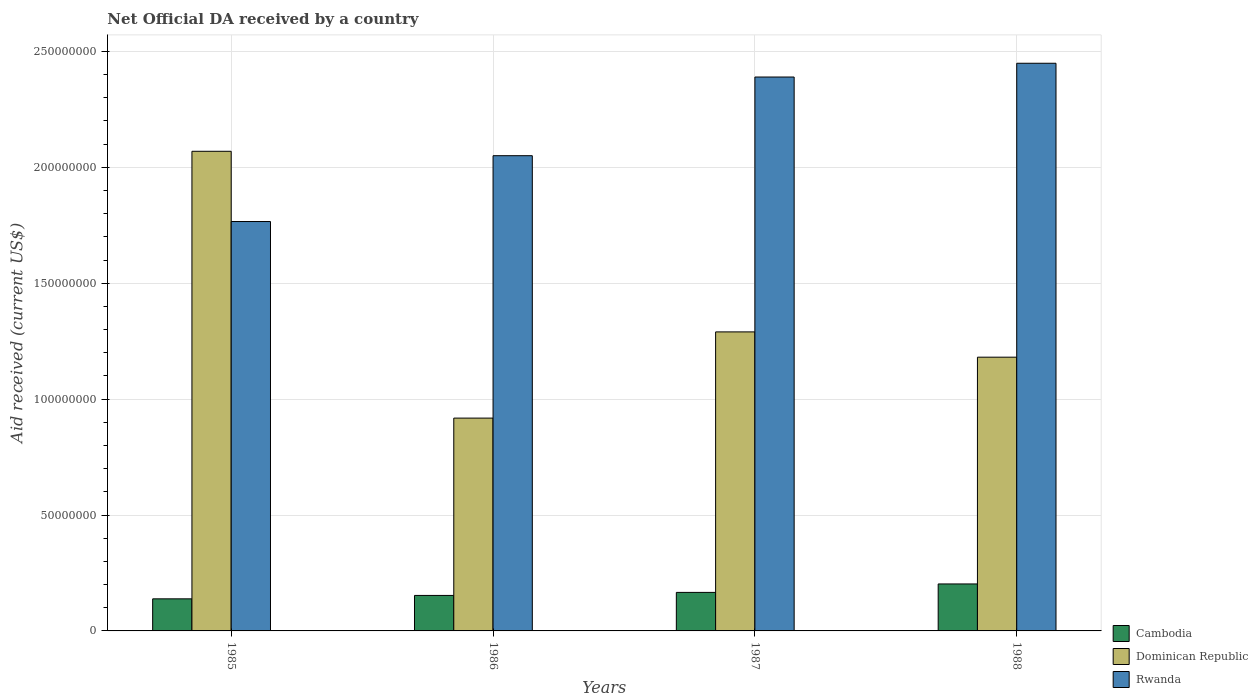How many groups of bars are there?
Make the answer very short. 4. How many bars are there on the 1st tick from the left?
Offer a very short reply. 3. How many bars are there on the 2nd tick from the right?
Offer a terse response. 3. In how many cases, is the number of bars for a given year not equal to the number of legend labels?
Provide a short and direct response. 0. What is the net official development assistance aid received in Cambodia in 1986?
Offer a very short reply. 1.53e+07. Across all years, what is the maximum net official development assistance aid received in Rwanda?
Offer a terse response. 2.45e+08. Across all years, what is the minimum net official development assistance aid received in Rwanda?
Offer a very short reply. 1.77e+08. In which year was the net official development assistance aid received in Cambodia minimum?
Keep it short and to the point. 1985. What is the total net official development assistance aid received in Rwanda in the graph?
Provide a succinct answer. 8.66e+08. What is the difference between the net official development assistance aid received in Dominican Republic in 1985 and that in 1986?
Give a very brief answer. 1.15e+08. What is the difference between the net official development assistance aid received in Rwanda in 1986 and the net official development assistance aid received in Cambodia in 1988?
Provide a succinct answer. 1.85e+08. What is the average net official development assistance aid received in Dominican Republic per year?
Make the answer very short. 1.36e+08. In the year 1986, what is the difference between the net official development assistance aid received in Rwanda and net official development assistance aid received in Dominican Republic?
Provide a succinct answer. 1.13e+08. In how many years, is the net official development assistance aid received in Cambodia greater than 40000000 US$?
Your response must be concise. 0. What is the ratio of the net official development assistance aid received in Dominican Republic in 1986 to that in 1988?
Make the answer very short. 0.78. Is the difference between the net official development assistance aid received in Rwanda in 1987 and 1988 greater than the difference between the net official development assistance aid received in Dominican Republic in 1987 and 1988?
Provide a succinct answer. No. What is the difference between the highest and the second highest net official development assistance aid received in Dominican Republic?
Keep it short and to the point. 7.79e+07. What is the difference between the highest and the lowest net official development assistance aid received in Cambodia?
Your response must be concise. 6.43e+06. What does the 3rd bar from the left in 1986 represents?
Your answer should be very brief. Rwanda. What does the 2nd bar from the right in 1988 represents?
Offer a terse response. Dominican Republic. Are all the bars in the graph horizontal?
Your response must be concise. No. How many years are there in the graph?
Offer a terse response. 4. What is the difference between two consecutive major ticks on the Y-axis?
Your answer should be compact. 5.00e+07. Where does the legend appear in the graph?
Ensure brevity in your answer.  Bottom right. How many legend labels are there?
Provide a succinct answer. 3. What is the title of the graph?
Offer a terse response. Net Official DA received by a country. What is the label or title of the X-axis?
Provide a succinct answer. Years. What is the label or title of the Y-axis?
Your response must be concise. Aid received (current US$). What is the Aid received (current US$) of Cambodia in 1985?
Offer a terse response. 1.38e+07. What is the Aid received (current US$) in Dominican Republic in 1985?
Ensure brevity in your answer.  2.07e+08. What is the Aid received (current US$) of Rwanda in 1985?
Give a very brief answer. 1.77e+08. What is the Aid received (current US$) in Cambodia in 1986?
Provide a succinct answer. 1.53e+07. What is the Aid received (current US$) of Dominican Republic in 1986?
Give a very brief answer. 9.18e+07. What is the Aid received (current US$) in Rwanda in 1986?
Give a very brief answer. 2.05e+08. What is the Aid received (current US$) in Cambodia in 1987?
Give a very brief answer. 1.66e+07. What is the Aid received (current US$) in Dominican Republic in 1987?
Give a very brief answer. 1.29e+08. What is the Aid received (current US$) in Rwanda in 1987?
Keep it short and to the point. 2.39e+08. What is the Aid received (current US$) of Cambodia in 1988?
Ensure brevity in your answer.  2.03e+07. What is the Aid received (current US$) of Dominican Republic in 1988?
Your response must be concise. 1.18e+08. What is the Aid received (current US$) of Rwanda in 1988?
Keep it short and to the point. 2.45e+08. Across all years, what is the maximum Aid received (current US$) of Cambodia?
Provide a succinct answer. 2.03e+07. Across all years, what is the maximum Aid received (current US$) in Dominican Republic?
Keep it short and to the point. 2.07e+08. Across all years, what is the maximum Aid received (current US$) in Rwanda?
Your answer should be compact. 2.45e+08. Across all years, what is the minimum Aid received (current US$) in Cambodia?
Provide a succinct answer. 1.38e+07. Across all years, what is the minimum Aid received (current US$) in Dominican Republic?
Provide a succinct answer. 9.18e+07. Across all years, what is the minimum Aid received (current US$) in Rwanda?
Your answer should be very brief. 1.77e+08. What is the total Aid received (current US$) in Cambodia in the graph?
Your response must be concise. 6.60e+07. What is the total Aid received (current US$) in Dominican Republic in the graph?
Offer a very short reply. 5.46e+08. What is the total Aid received (current US$) of Rwanda in the graph?
Make the answer very short. 8.66e+08. What is the difference between the Aid received (current US$) in Cambodia in 1985 and that in 1986?
Your answer should be very brief. -1.47e+06. What is the difference between the Aid received (current US$) of Dominican Republic in 1985 and that in 1986?
Give a very brief answer. 1.15e+08. What is the difference between the Aid received (current US$) of Rwanda in 1985 and that in 1986?
Give a very brief answer. -2.84e+07. What is the difference between the Aid received (current US$) in Cambodia in 1985 and that in 1987?
Offer a terse response. -2.78e+06. What is the difference between the Aid received (current US$) of Dominican Republic in 1985 and that in 1987?
Keep it short and to the point. 7.79e+07. What is the difference between the Aid received (current US$) of Rwanda in 1985 and that in 1987?
Offer a very short reply. -6.23e+07. What is the difference between the Aid received (current US$) of Cambodia in 1985 and that in 1988?
Provide a succinct answer. -6.43e+06. What is the difference between the Aid received (current US$) in Dominican Republic in 1985 and that in 1988?
Keep it short and to the point. 8.88e+07. What is the difference between the Aid received (current US$) in Rwanda in 1985 and that in 1988?
Keep it short and to the point. -6.83e+07. What is the difference between the Aid received (current US$) in Cambodia in 1986 and that in 1987?
Ensure brevity in your answer.  -1.31e+06. What is the difference between the Aid received (current US$) of Dominican Republic in 1986 and that in 1987?
Ensure brevity in your answer.  -3.72e+07. What is the difference between the Aid received (current US$) in Rwanda in 1986 and that in 1987?
Give a very brief answer. -3.39e+07. What is the difference between the Aid received (current US$) in Cambodia in 1986 and that in 1988?
Make the answer very short. -4.96e+06. What is the difference between the Aid received (current US$) in Dominican Republic in 1986 and that in 1988?
Provide a short and direct response. -2.63e+07. What is the difference between the Aid received (current US$) in Rwanda in 1986 and that in 1988?
Your response must be concise. -3.99e+07. What is the difference between the Aid received (current US$) of Cambodia in 1987 and that in 1988?
Your answer should be compact. -3.65e+06. What is the difference between the Aid received (current US$) of Dominican Republic in 1987 and that in 1988?
Provide a short and direct response. 1.09e+07. What is the difference between the Aid received (current US$) of Rwanda in 1987 and that in 1988?
Your response must be concise. -5.94e+06. What is the difference between the Aid received (current US$) of Cambodia in 1985 and the Aid received (current US$) of Dominican Republic in 1986?
Make the answer very short. -7.80e+07. What is the difference between the Aid received (current US$) of Cambodia in 1985 and the Aid received (current US$) of Rwanda in 1986?
Make the answer very short. -1.91e+08. What is the difference between the Aid received (current US$) of Dominican Republic in 1985 and the Aid received (current US$) of Rwanda in 1986?
Give a very brief answer. 1.90e+06. What is the difference between the Aid received (current US$) of Cambodia in 1985 and the Aid received (current US$) of Dominican Republic in 1987?
Keep it short and to the point. -1.15e+08. What is the difference between the Aid received (current US$) of Cambodia in 1985 and the Aid received (current US$) of Rwanda in 1987?
Keep it short and to the point. -2.25e+08. What is the difference between the Aid received (current US$) in Dominican Republic in 1985 and the Aid received (current US$) in Rwanda in 1987?
Your answer should be compact. -3.20e+07. What is the difference between the Aid received (current US$) of Cambodia in 1985 and the Aid received (current US$) of Dominican Republic in 1988?
Provide a short and direct response. -1.04e+08. What is the difference between the Aid received (current US$) of Cambodia in 1985 and the Aid received (current US$) of Rwanda in 1988?
Provide a succinct answer. -2.31e+08. What is the difference between the Aid received (current US$) in Dominican Republic in 1985 and the Aid received (current US$) in Rwanda in 1988?
Your response must be concise. -3.80e+07. What is the difference between the Aid received (current US$) of Cambodia in 1986 and the Aid received (current US$) of Dominican Republic in 1987?
Your answer should be very brief. -1.14e+08. What is the difference between the Aid received (current US$) in Cambodia in 1986 and the Aid received (current US$) in Rwanda in 1987?
Give a very brief answer. -2.24e+08. What is the difference between the Aid received (current US$) in Dominican Republic in 1986 and the Aid received (current US$) in Rwanda in 1987?
Your response must be concise. -1.47e+08. What is the difference between the Aid received (current US$) of Cambodia in 1986 and the Aid received (current US$) of Dominican Republic in 1988?
Offer a very short reply. -1.03e+08. What is the difference between the Aid received (current US$) of Cambodia in 1986 and the Aid received (current US$) of Rwanda in 1988?
Keep it short and to the point. -2.30e+08. What is the difference between the Aid received (current US$) in Dominican Republic in 1986 and the Aid received (current US$) in Rwanda in 1988?
Offer a terse response. -1.53e+08. What is the difference between the Aid received (current US$) in Cambodia in 1987 and the Aid received (current US$) in Dominican Republic in 1988?
Your response must be concise. -1.01e+08. What is the difference between the Aid received (current US$) in Cambodia in 1987 and the Aid received (current US$) in Rwanda in 1988?
Your response must be concise. -2.28e+08. What is the difference between the Aid received (current US$) of Dominican Republic in 1987 and the Aid received (current US$) of Rwanda in 1988?
Provide a short and direct response. -1.16e+08. What is the average Aid received (current US$) of Cambodia per year?
Give a very brief answer. 1.65e+07. What is the average Aid received (current US$) in Dominican Republic per year?
Provide a short and direct response. 1.36e+08. What is the average Aid received (current US$) of Rwanda per year?
Give a very brief answer. 2.16e+08. In the year 1985, what is the difference between the Aid received (current US$) in Cambodia and Aid received (current US$) in Dominican Republic?
Offer a very short reply. -1.93e+08. In the year 1985, what is the difference between the Aid received (current US$) in Cambodia and Aid received (current US$) in Rwanda?
Provide a short and direct response. -1.63e+08. In the year 1985, what is the difference between the Aid received (current US$) of Dominican Republic and Aid received (current US$) of Rwanda?
Ensure brevity in your answer.  3.03e+07. In the year 1986, what is the difference between the Aid received (current US$) of Cambodia and Aid received (current US$) of Dominican Republic?
Give a very brief answer. -7.65e+07. In the year 1986, what is the difference between the Aid received (current US$) in Cambodia and Aid received (current US$) in Rwanda?
Provide a succinct answer. -1.90e+08. In the year 1986, what is the difference between the Aid received (current US$) in Dominican Republic and Aid received (current US$) in Rwanda?
Provide a succinct answer. -1.13e+08. In the year 1987, what is the difference between the Aid received (current US$) in Cambodia and Aid received (current US$) in Dominican Republic?
Make the answer very short. -1.12e+08. In the year 1987, what is the difference between the Aid received (current US$) of Cambodia and Aid received (current US$) of Rwanda?
Ensure brevity in your answer.  -2.22e+08. In the year 1987, what is the difference between the Aid received (current US$) in Dominican Republic and Aid received (current US$) in Rwanda?
Give a very brief answer. -1.10e+08. In the year 1988, what is the difference between the Aid received (current US$) of Cambodia and Aid received (current US$) of Dominican Republic?
Your answer should be very brief. -9.78e+07. In the year 1988, what is the difference between the Aid received (current US$) of Cambodia and Aid received (current US$) of Rwanda?
Keep it short and to the point. -2.25e+08. In the year 1988, what is the difference between the Aid received (current US$) in Dominican Republic and Aid received (current US$) in Rwanda?
Offer a terse response. -1.27e+08. What is the ratio of the Aid received (current US$) in Cambodia in 1985 to that in 1986?
Make the answer very short. 0.9. What is the ratio of the Aid received (current US$) in Dominican Republic in 1985 to that in 1986?
Offer a very short reply. 2.25. What is the ratio of the Aid received (current US$) of Rwanda in 1985 to that in 1986?
Keep it short and to the point. 0.86. What is the ratio of the Aid received (current US$) in Cambodia in 1985 to that in 1987?
Offer a terse response. 0.83. What is the ratio of the Aid received (current US$) of Dominican Republic in 1985 to that in 1987?
Offer a very short reply. 1.6. What is the ratio of the Aid received (current US$) of Rwanda in 1985 to that in 1987?
Offer a terse response. 0.74. What is the ratio of the Aid received (current US$) of Cambodia in 1985 to that in 1988?
Your response must be concise. 0.68. What is the ratio of the Aid received (current US$) of Dominican Republic in 1985 to that in 1988?
Your response must be concise. 1.75. What is the ratio of the Aid received (current US$) in Rwanda in 1985 to that in 1988?
Provide a succinct answer. 0.72. What is the ratio of the Aid received (current US$) of Cambodia in 1986 to that in 1987?
Your response must be concise. 0.92. What is the ratio of the Aid received (current US$) of Dominican Republic in 1986 to that in 1987?
Provide a short and direct response. 0.71. What is the ratio of the Aid received (current US$) of Rwanda in 1986 to that in 1987?
Offer a very short reply. 0.86. What is the ratio of the Aid received (current US$) of Cambodia in 1986 to that in 1988?
Provide a succinct answer. 0.76. What is the ratio of the Aid received (current US$) of Dominican Republic in 1986 to that in 1988?
Your answer should be compact. 0.78. What is the ratio of the Aid received (current US$) of Rwanda in 1986 to that in 1988?
Offer a terse response. 0.84. What is the ratio of the Aid received (current US$) of Cambodia in 1987 to that in 1988?
Make the answer very short. 0.82. What is the ratio of the Aid received (current US$) of Dominican Republic in 1987 to that in 1988?
Ensure brevity in your answer.  1.09. What is the ratio of the Aid received (current US$) of Rwanda in 1987 to that in 1988?
Give a very brief answer. 0.98. What is the difference between the highest and the second highest Aid received (current US$) in Cambodia?
Give a very brief answer. 3.65e+06. What is the difference between the highest and the second highest Aid received (current US$) of Dominican Republic?
Offer a very short reply. 7.79e+07. What is the difference between the highest and the second highest Aid received (current US$) in Rwanda?
Offer a very short reply. 5.94e+06. What is the difference between the highest and the lowest Aid received (current US$) in Cambodia?
Make the answer very short. 6.43e+06. What is the difference between the highest and the lowest Aid received (current US$) in Dominican Republic?
Give a very brief answer. 1.15e+08. What is the difference between the highest and the lowest Aid received (current US$) of Rwanda?
Offer a very short reply. 6.83e+07. 